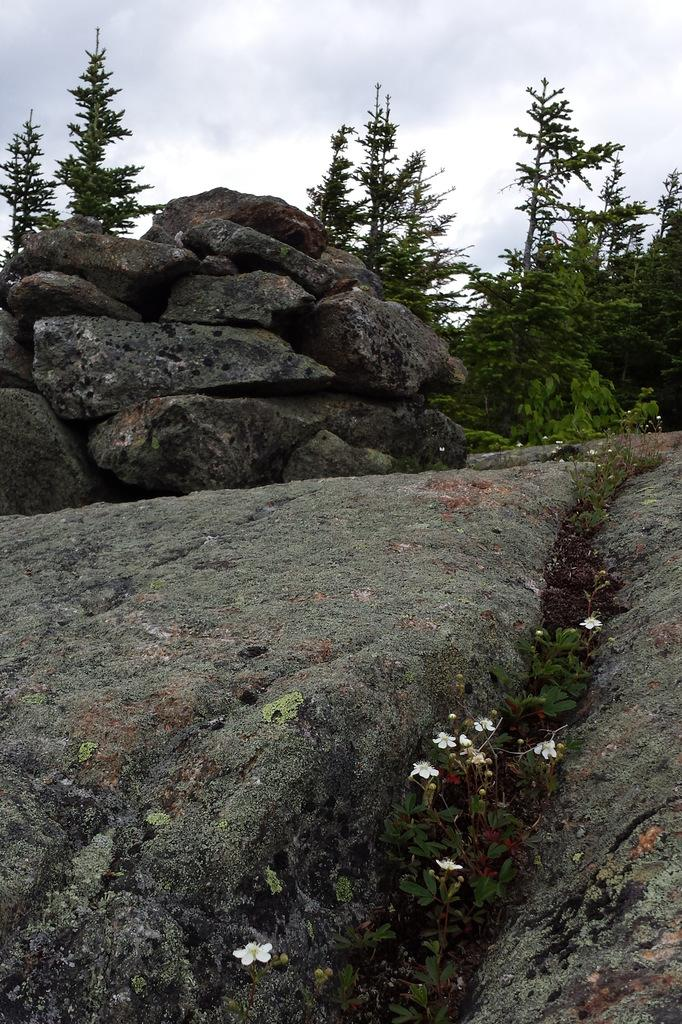What type of flowers can be seen in the image? There are white color flowers in the image. What other objects or elements are present in the image? There are rocks and trees in the image. How would you describe the sky in the background of the image? The sky is cloudy in the background of the image. Where is the cushion placed in the image? There is no cushion present in the image. What type of engine can be seen in the image? There is no engine present in the image. 